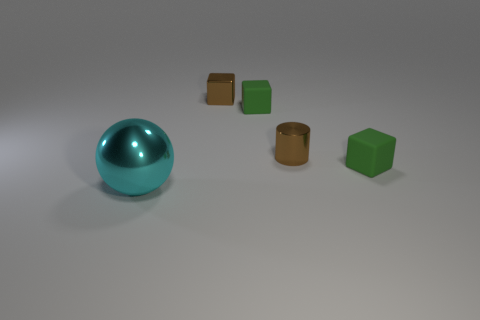Subtract all small rubber blocks. How many blocks are left? 1 Add 1 tiny metallic objects. How many objects exist? 6 Subtract all red balls. How many green blocks are left? 2 Subtract all brown blocks. How many blocks are left? 2 Subtract 0 red blocks. How many objects are left? 5 Subtract all cylinders. How many objects are left? 4 Subtract 1 blocks. How many blocks are left? 2 Subtract all yellow cylinders. Subtract all cyan cubes. How many cylinders are left? 1 Subtract all tiny cyan rubber cubes. Subtract all tiny cylinders. How many objects are left? 4 Add 3 metal objects. How many metal objects are left? 6 